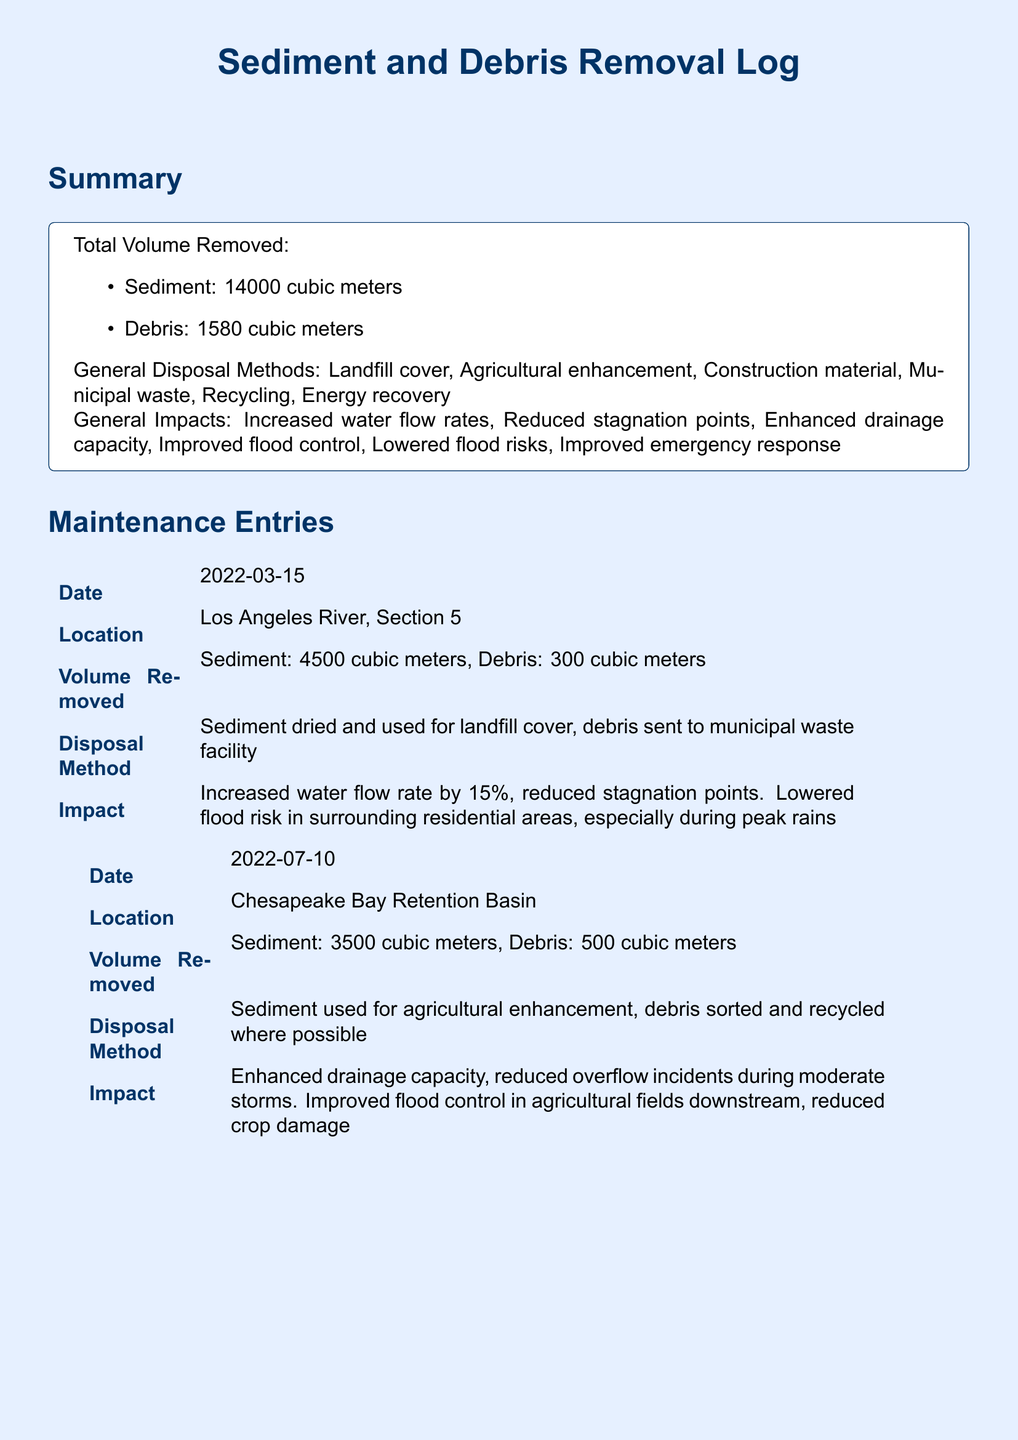What is the total volume of sediment removed? The total volume of sediment removed is stated in the summary section of the document.
Answer: 14000 cubic meters What was the volume of debris removed on 2022-07-10? The volume of debris removed on that date is specified in the maintenance entry.
Answer: 500 cubic meters Which disposal method was used for the debris on 2023-01-20? The disposal method for the debris on that date is provided in the maintenance entry.
Answer: combusted in energy recovery facility What was the increased water flow rate after the maintenance on 2022-03-15? The impact section of that maintenance entry mentions the specific increase in water flow rate.
Answer: 15 percent How much sediment was removed from the Chesapeake Bay Retention Basin? The maintenance entry for that date details the volume of sediment removed.
Answer: 3500 cubic meters Which location had a reported improvement in emergency response times? The location associated with improved emergency response times is mentioned in the impact section of one of the entries.
Answer: Houston Bayou System What general impacts are noted in the log? The summary section lists several general impacts of the maintenance actions.
Answer: Increased water flow rates What date corresponds to the largest amount of sediment removal? The maintenance entries provide specific dates along with the associated volumes of sediment removed.
Answer: 2023-01-20 Which disposal method is associated with agricultural enhancement? The disposal method linked to agricultural enhancement is found in one of the maintenance entries.
Answer: Sediment used for agricultural enhancement 